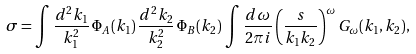<formula> <loc_0><loc_0><loc_500><loc_500>\sigma = \int \frac { d ^ { 2 } k _ { 1 } } { k _ { 1 } ^ { 2 } } \, \Phi _ { A } ( k _ { 1 } ) \, \frac { d ^ { 2 } k _ { 2 } } { k _ { 2 } ^ { 2 } } \, \Phi _ { B } ( k _ { 2 } ) \, \int \frac { d \omega } { 2 \pi i } \left ( \frac { s } { k _ { 1 } k _ { 2 } } \right ) ^ { \omega } G _ { \omega } ( k _ { 1 } , k _ { 2 } ) ,</formula> 